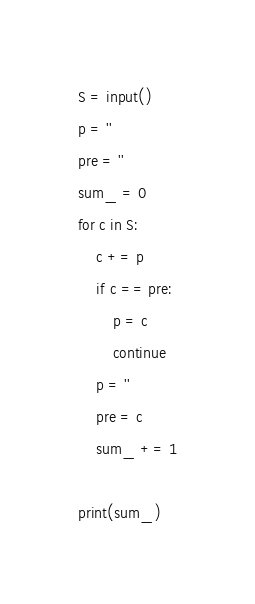<code> <loc_0><loc_0><loc_500><loc_500><_Python_>S = input()
p = ''
pre = ''
sum_ = 0
for c in S:
    c += p
    if c == pre:
        p = c
        continue
    p = ''
    pre = c
    sum_ += 1

print(sum_)</code> 